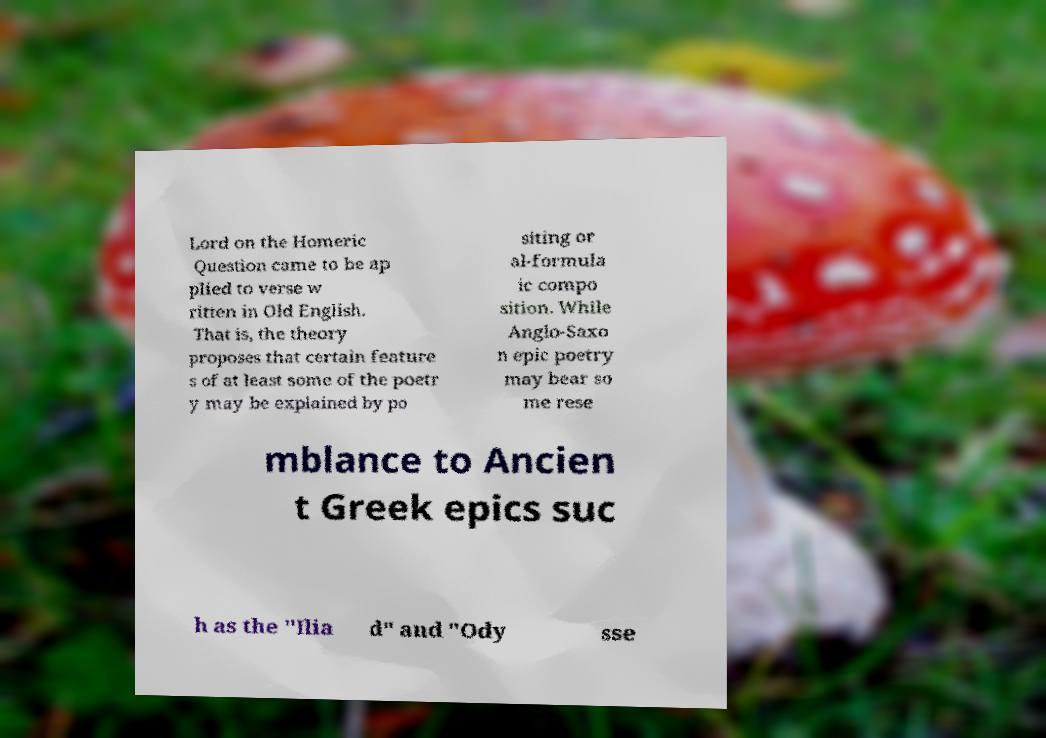Could you assist in decoding the text presented in this image and type it out clearly? Lord on the Homeric Question came to be ap plied to verse w ritten in Old English. That is, the theory proposes that certain feature s of at least some of the poetr y may be explained by po siting or al-formula ic compo sition. While Anglo-Saxo n epic poetry may bear so me rese mblance to Ancien t Greek epics suc h as the "Ilia d" and "Ody sse 